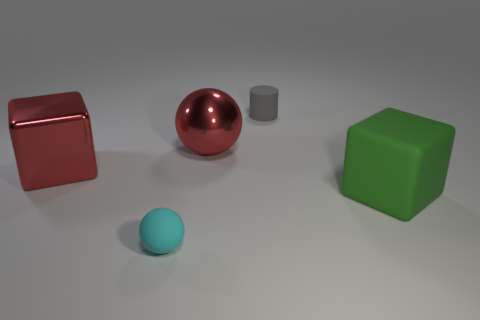Subtract all red blocks. How many blocks are left? 1 Add 1 big red metal cubes. How many objects exist? 6 Subtract all cylinders. How many objects are left? 4 Subtract 0 red cylinders. How many objects are left? 5 Subtract all brown cubes. Subtract all green cylinders. How many cubes are left? 2 Subtract all cyan cubes. How many red spheres are left? 1 Subtract all gray spheres. Subtract all red metal cubes. How many objects are left? 4 Add 2 spheres. How many spheres are left? 4 Add 3 big metallic objects. How many big metallic objects exist? 5 